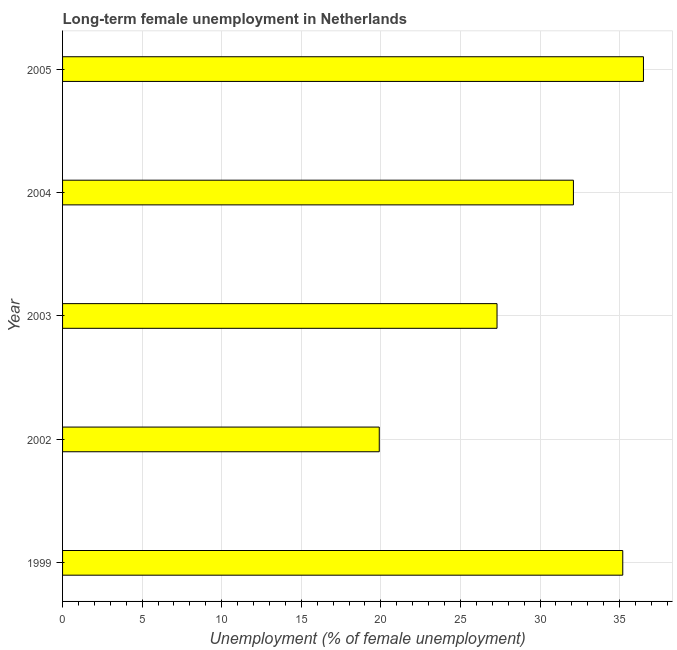Does the graph contain any zero values?
Offer a very short reply. No. What is the title of the graph?
Provide a succinct answer. Long-term female unemployment in Netherlands. What is the label or title of the X-axis?
Offer a very short reply. Unemployment (% of female unemployment). What is the label or title of the Y-axis?
Ensure brevity in your answer.  Year. What is the long-term female unemployment in 2003?
Make the answer very short. 27.3. Across all years, what is the maximum long-term female unemployment?
Offer a very short reply. 36.5. Across all years, what is the minimum long-term female unemployment?
Your response must be concise. 19.9. In which year was the long-term female unemployment maximum?
Your answer should be compact. 2005. In which year was the long-term female unemployment minimum?
Ensure brevity in your answer.  2002. What is the sum of the long-term female unemployment?
Ensure brevity in your answer.  151. What is the average long-term female unemployment per year?
Make the answer very short. 30.2. What is the median long-term female unemployment?
Offer a very short reply. 32.1. In how many years, is the long-term female unemployment greater than 4 %?
Ensure brevity in your answer.  5. Do a majority of the years between 2003 and 2005 (inclusive) have long-term female unemployment greater than 36 %?
Make the answer very short. No. What is the ratio of the long-term female unemployment in 2003 to that in 2005?
Offer a very short reply. 0.75. Is the difference between the long-term female unemployment in 2002 and 2005 greater than the difference between any two years?
Your answer should be very brief. Yes. What is the difference between the highest and the second highest long-term female unemployment?
Offer a very short reply. 1.3. In how many years, is the long-term female unemployment greater than the average long-term female unemployment taken over all years?
Make the answer very short. 3. How many bars are there?
Give a very brief answer. 5. How many years are there in the graph?
Offer a very short reply. 5. Are the values on the major ticks of X-axis written in scientific E-notation?
Your response must be concise. No. What is the Unemployment (% of female unemployment) in 1999?
Your answer should be very brief. 35.2. What is the Unemployment (% of female unemployment) of 2002?
Provide a succinct answer. 19.9. What is the Unemployment (% of female unemployment) in 2003?
Keep it short and to the point. 27.3. What is the Unemployment (% of female unemployment) of 2004?
Keep it short and to the point. 32.1. What is the Unemployment (% of female unemployment) of 2005?
Offer a very short reply. 36.5. What is the difference between the Unemployment (% of female unemployment) in 1999 and 2003?
Keep it short and to the point. 7.9. What is the difference between the Unemployment (% of female unemployment) in 1999 and 2005?
Provide a short and direct response. -1.3. What is the difference between the Unemployment (% of female unemployment) in 2002 and 2003?
Your answer should be very brief. -7.4. What is the difference between the Unemployment (% of female unemployment) in 2002 and 2004?
Your answer should be very brief. -12.2. What is the difference between the Unemployment (% of female unemployment) in 2002 and 2005?
Your answer should be very brief. -16.6. What is the difference between the Unemployment (% of female unemployment) in 2003 and 2004?
Give a very brief answer. -4.8. What is the difference between the Unemployment (% of female unemployment) in 2003 and 2005?
Your response must be concise. -9.2. What is the difference between the Unemployment (% of female unemployment) in 2004 and 2005?
Offer a terse response. -4.4. What is the ratio of the Unemployment (% of female unemployment) in 1999 to that in 2002?
Offer a very short reply. 1.77. What is the ratio of the Unemployment (% of female unemployment) in 1999 to that in 2003?
Your answer should be compact. 1.29. What is the ratio of the Unemployment (% of female unemployment) in 1999 to that in 2004?
Provide a short and direct response. 1.1. What is the ratio of the Unemployment (% of female unemployment) in 2002 to that in 2003?
Provide a short and direct response. 0.73. What is the ratio of the Unemployment (% of female unemployment) in 2002 to that in 2004?
Provide a succinct answer. 0.62. What is the ratio of the Unemployment (% of female unemployment) in 2002 to that in 2005?
Provide a succinct answer. 0.55. What is the ratio of the Unemployment (% of female unemployment) in 2003 to that in 2005?
Your answer should be very brief. 0.75. What is the ratio of the Unemployment (% of female unemployment) in 2004 to that in 2005?
Provide a short and direct response. 0.88. 